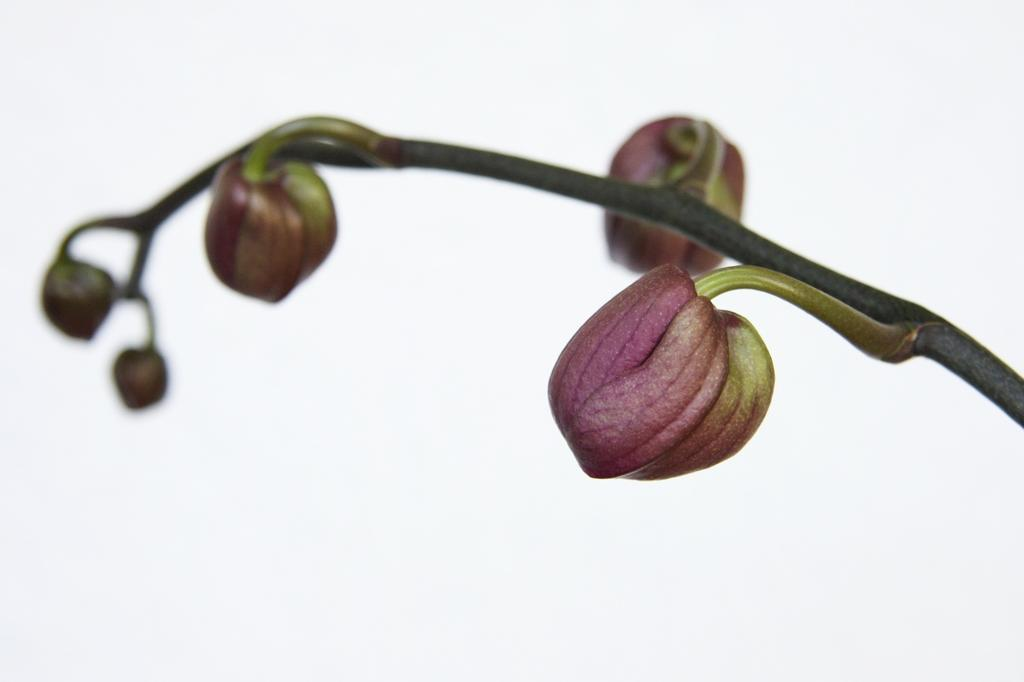What type of plant organ is depicted in the image? The image contains flower buds. What color are the flower buds? The flower buds are pink in color. What is the background color of the image? The background of the image is white. What type of weather can be seen in the image? There is no weather depicted in the image, as it only shows flower buds and a white background. 